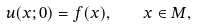<formula> <loc_0><loc_0><loc_500><loc_500>u ( x ; 0 ) = f ( x ) , \quad x \in M ,</formula> 